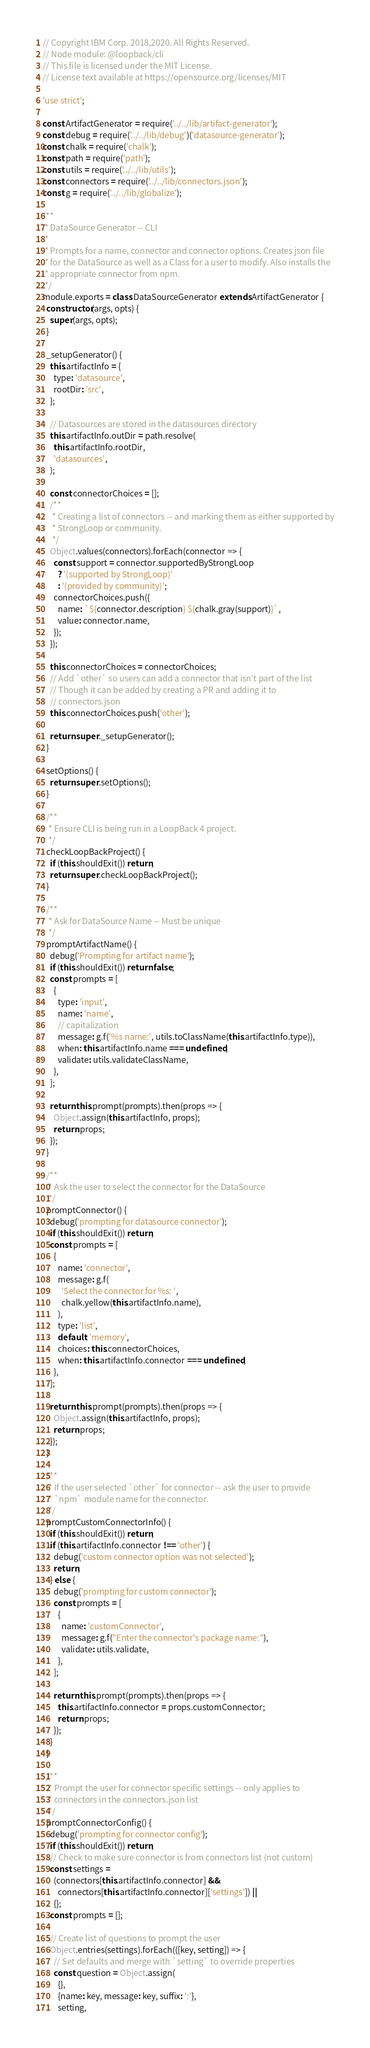<code> <loc_0><loc_0><loc_500><loc_500><_JavaScript_>// Copyright IBM Corp. 2018,2020. All Rights Reserved.
// Node module: @loopback/cli
// This file is licensed under the MIT License.
// License text available at https://opensource.org/licenses/MIT

'use strict';

const ArtifactGenerator = require('../../lib/artifact-generator');
const debug = require('../../lib/debug')('datasource-generator');
const chalk = require('chalk');
const path = require('path');
const utils = require('../../lib/utils');
const connectors = require('../../lib/connectors.json');
const g = require('../../lib/globalize');

/**
 * DataSource Generator -- CLI
 *
 * Prompts for a name, connector and connector options. Creates json file
 * for the DataSource as well as a Class for a user to modify. Also installs the
 * appropriate connector from npm.
 */
module.exports = class DataSourceGenerator extends ArtifactGenerator {
  constructor(args, opts) {
    super(args, opts);
  }

  _setupGenerator() {
    this.artifactInfo = {
      type: 'datasource',
      rootDir: 'src',
    };

    // Datasources are stored in the datasources directory
    this.artifactInfo.outDir = path.resolve(
      this.artifactInfo.rootDir,
      'datasources',
    );

    const connectorChoices = [];
    /**
     * Creating a list of connectors -- and marking them as either supported by
     * StrongLoop or community.
     */
    Object.values(connectors).forEach(connector => {
      const support = connector.supportedByStrongLoop
        ? '(supported by StrongLoop)'
        : '(provided by community)';
      connectorChoices.push({
        name: `${connector.description} ${chalk.gray(support)}`,
        value: connector.name,
      });
    });

    this.connectorChoices = connectorChoices;
    // Add `other` so users can add a connector that isn't part of the list
    // Though it can be added by creating a PR and adding it to
    // connectors.json
    this.connectorChoices.push('other');

    return super._setupGenerator();
  }

  setOptions() {
    return super.setOptions();
  }

  /**
   * Ensure CLI is being run in a LoopBack 4 project.
   */
  checkLoopBackProject() {
    if (this.shouldExit()) return;
    return super.checkLoopBackProject();
  }

  /**
   * Ask for DataSource Name -- Must be unique
   */
  promptArtifactName() {
    debug('Prompting for artifact name');
    if (this.shouldExit()) return false;
    const prompts = [
      {
        type: 'input',
        name: 'name',
        // capitalization
        message: g.f('%s name:', utils.toClassName(this.artifactInfo.type)),
        when: this.artifactInfo.name === undefined,
        validate: utils.validateClassName,
      },
    ];

    return this.prompt(prompts).then(props => {
      Object.assign(this.artifactInfo, props);
      return props;
    });
  }

  /**
   * Ask the user to select the connector for the DataSource
   */
  promptConnector() {
    debug('prompting for datasource connector');
    if (this.shouldExit()) return;
    const prompts = [
      {
        name: 'connector',
        message: g.f(
          'Select the connector for %s: ',
          chalk.yellow(this.artifactInfo.name),
        ),
        type: 'list',
        default: 'memory',
        choices: this.connectorChoices,
        when: this.artifactInfo.connector === undefined,
      },
    ];

    return this.prompt(prompts).then(props => {
      Object.assign(this.artifactInfo, props);
      return props;
    });
  }

  /**
   * If the user selected `other` for connector -- ask the user to provide
   * `npm` module name for the connector.
   */
  promptCustomConnectorInfo() {
    if (this.shouldExit()) return;
    if (this.artifactInfo.connector !== 'other') {
      debug('custom connector option was not selected');
      return;
    } else {
      debug('prompting for custom connector');
      const prompts = [
        {
          name: 'customConnector',
          message: g.f("Enter the connector's package name:"),
          validate: utils.validate,
        },
      ];

      return this.prompt(prompts).then(props => {
        this.artifactInfo.connector = props.customConnector;
        return props;
      });
    }
  }

  /**
   * Prompt the user for connector specific settings -- only applies to
   * connectors in the connectors.json list
   */
  promptConnectorConfig() {
    debug('prompting for connector config');
    if (this.shouldExit()) return;
    // Check to make sure connector is from connectors list (not custom)
    const settings =
      (connectors[this.artifactInfo.connector] &&
        connectors[this.artifactInfo.connector]['settings']) ||
      {};
    const prompts = [];

    // Create list of questions to prompt the user
    Object.entries(settings).forEach(([key, setting]) => {
      // Set defaults and merge with `setting` to override properties
      const question = Object.assign(
        {},
        {name: key, message: key, suffix: ':'},
        setting,</code> 